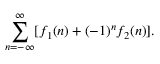Convert formula to latex. <formula><loc_0><loc_0><loc_500><loc_500>\sum _ { n = - \infty } ^ { \infty } [ f _ { 1 } ( n ) + ( - 1 ) ^ { n } f _ { 2 } ( n ) ] .</formula> 